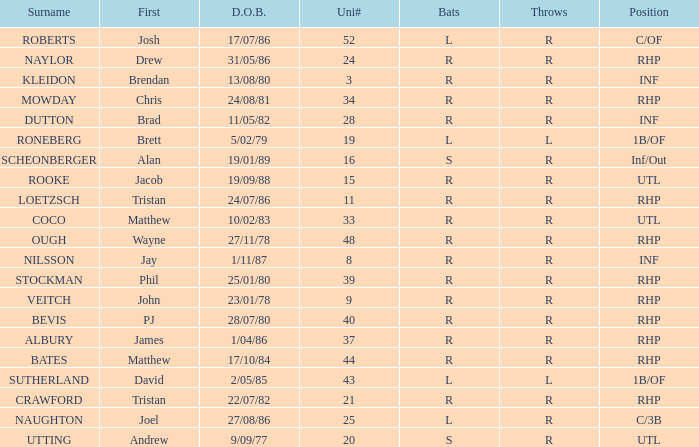Which Uni # has a Surname of ough? 48.0. Parse the table in full. {'header': ['Surname', 'First', 'D.O.B.', 'Uni#', 'Bats', 'Throws', 'Position'], 'rows': [['ROBERTS', 'Josh', '17/07/86', '52', 'L', 'R', 'C/OF'], ['NAYLOR', 'Drew', '31/05/86', '24', 'R', 'R', 'RHP'], ['KLEIDON', 'Brendan', '13/08/80', '3', 'R', 'R', 'INF'], ['MOWDAY', 'Chris', '24/08/81', '34', 'R', 'R', 'RHP'], ['DUTTON', 'Brad', '11/05/82', '28', 'R', 'R', 'INF'], ['RONEBERG', 'Brett', '5/02/79', '19', 'L', 'L', '1B/OF'], ['SCHEONBERGER', 'Alan', '19/01/89', '16', 'S', 'R', 'Inf/Out'], ['ROOKE', 'Jacob', '19/09/88', '15', 'R', 'R', 'UTL'], ['LOETZSCH', 'Tristan', '24/07/86', '11', 'R', 'R', 'RHP'], ['COCO', 'Matthew', '10/02/83', '33', 'R', 'R', 'UTL'], ['OUGH', 'Wayne', '27/11/78', '48', 'R', 'R', 'RHP'], ['NILSSON', 'Jay', '1/11/87', '8', 'R', 'R', 'INF'], ['STOCKMAN', 'Phil', '25/01/80', '39', 'R', 'R', 'RHP'], ['VEITCH', 'John', '23/01/78', '9', 'R', 'R', 'RHP'], ['BEVIS', 'PJ', '28/07/80', '40', 'R', 'R', 'RHP'], ['ALBURY', 'James', '1/04/86', '37', 'R', 'R', 'RHP'], ['BATES', 'Matthew', '17/10/84', '44', 'R', 'R', 'RHP'], ['SUTHERLAND', 'David', '2/05/85', '43', 'L', 'L', '1B/OF'], ['CRAWFORD', 'Tristan', '22/07/82', '21', 'R', 'R', 'RHP'], ['NAUGHTON', 'Joel', '27/08/86', '25', 'L', 'R', 'C/3B'], ['UTTING', 'Andrew', '9/09/77', '20', 'S', 'R', 'UTL']]} 